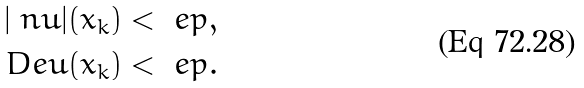<formula> <loc_0><loc_0><loc_500><loc_500>| \ n u | ( x _ { k } ) < \ e p , \\ \ D e u ( x _ { k } ) < \ e p .</formula> 